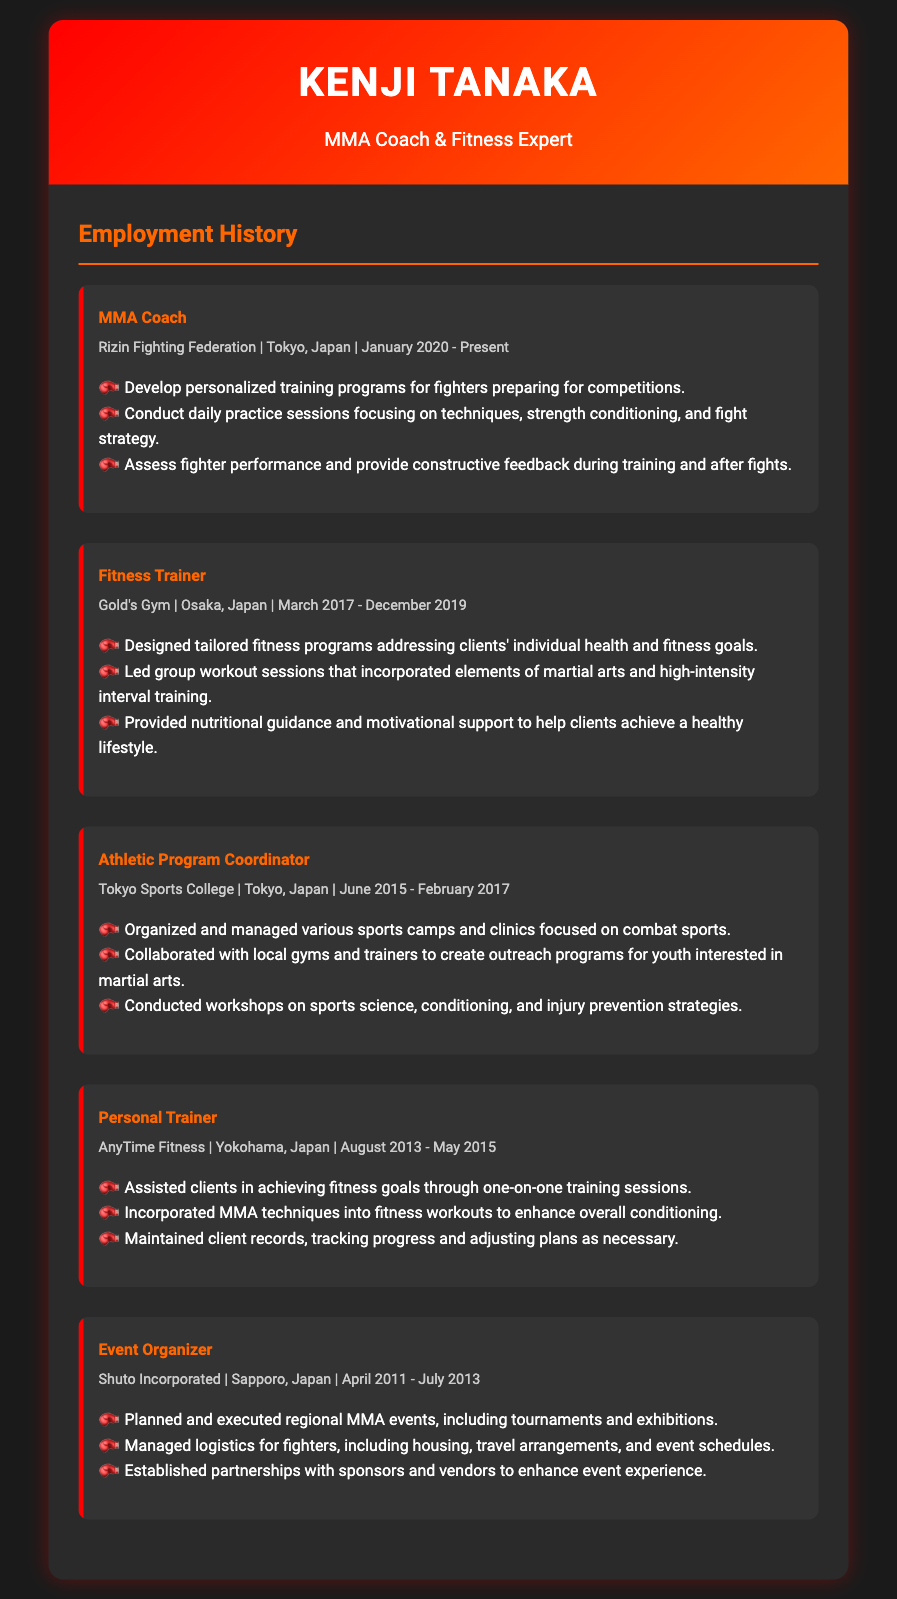What is the current job title of Kenji Tanaka? The job title listed as of January 2020 is "MMA Coach".
Answer: MMA Coach Which organization did Kenji Tanaka work for as a Fitness Trainer? The document states that he worked for "Gold's Gym" in Osaka, Japan.
Answer: Gold's Gym When did Kenji serve as an Athletic Program Coordinator? The document specifies the time frame as "June 2015 - February 2017".
Answer: June 2015 - February 2017 How many years was Kenji Tanaka a Personal Trainer? The Personal Trainer role lasted from "August 2013 to May 2015", which is approximately two years.
Answer: 2 years What city is Rizin Fighting Federation located in? The location mentioned in the document is "Tokyo, Japan".
Answer: Tokyo, Japan What primary responsibility did Kenji have as an MMA Coach? His primary responsibility includes developing training programs for fighters preparing for competitions.
Answer: Developing training programs How did Kenji integrate MMA into his role as a Fitness Trainer? He incorporated MMA techniques into fitness workouts to enhance overall conditioning.
Answer: Incorporating MMA techniques What event-related role did Kenji Tanaka have from April 2011 to July 2013? He worked as an "Event Organizer" for Shuto Incorporated.
Answer: Event Organizer What kind of sessions did Kenji lead at Gold's Gym? He led group workout sessions that incorporated martial arts and high-intensity interval training.
Answer: Group workout sessions 